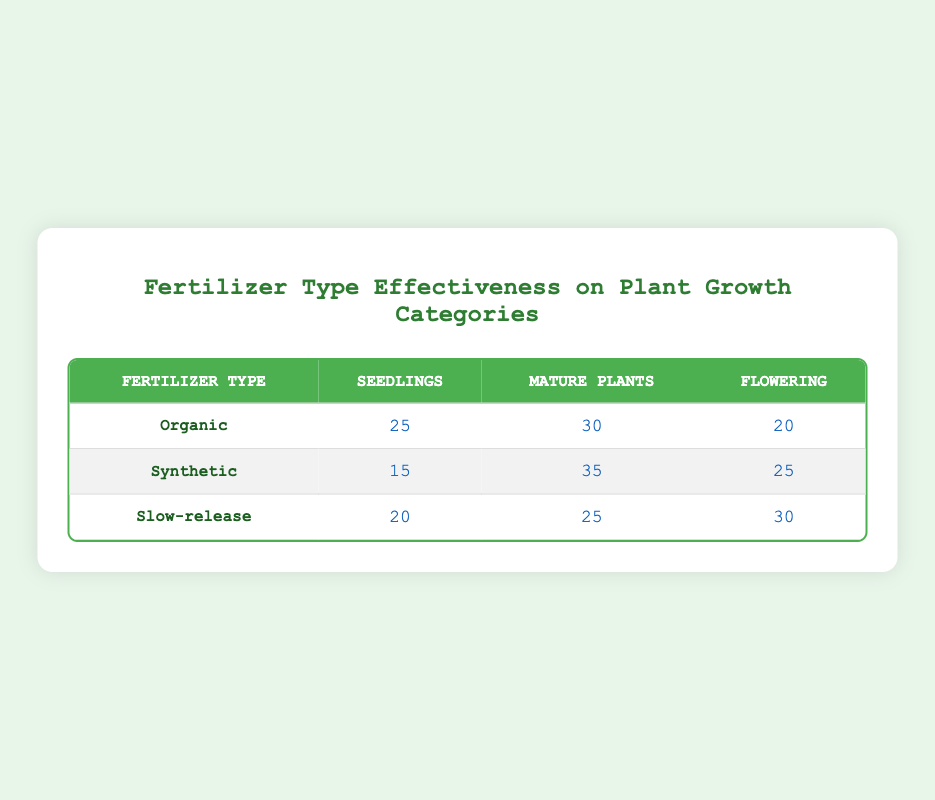What is the count of seedlings for organic fertilizer? According to the table, the count of seedlings under organic fertilizer specifically is listed as 25 in the corresponding cell.
Answer: 25 Which fertilizer type resulted in the highest count of mature plants? Looking at the mature plants column, the synthetic fertilizer shows a count of 35, which is the highest compared to organic (30) and slow-release (25).
Answer: Synthetic What is the total count of flowering plants across all fertilizer types? To find the total, we sum the counts of flowering plants: 20 (Organic) + 25 (Synthetic) + 30 (Slow-release) = 75.
Answer: 75 Did the slow-release fertilizer produce more flowering plants than the organic fertilizer? The count for slow-release flowering is 30, while for organic it is 20. Since 30 is greater than 20, the statement is true.
Answer: Yes What is the average count of seedlings across all fertilizer types? We total the counts of seedlings: 25 (Organic) + 15 (Synthetic) + 20 (Slow-release) = 60. Then, we divide by the number of fertilizer types (3), giving us an average of 20.
Answer: 20 Which fertilizer type has the lowest total count across all growth categories? We calculate the total for each type: Organic (25 + 30 + 20 = 75), Synthetic (15 + 35 + 25 = 75), Slow-release (20 + 25 + 30 = 75). All types end up with the same total, indicating no type has a lower count.
Answer: None Is the count of seedlings for synthetic fertilizer greater than the count for slow-release fertilizer? The count for seedlings with synthetic fertilizer is 15, while for slow-release it is 20. Since 15 is not greater than 20, the statement is false.
Answer: No What is the difference in counts between the highest and the lowest flowering counts? For flowering, the highest is 30 (Slow-release) and the lowest is 20 (Organic). The difference is calculated as 30 - 20 = 10.
Answer: 10 Which growth category had the highest total count across all fertilizer types? We calculate the totals for each category: Seedlings (25 + 15 + 20 = 60), Mature plants (30 + 35 + 25 = 90), Flowering (20 + 25 + 30 = 75). The highest is 90 for mature plants.
Answer: Mature plants 